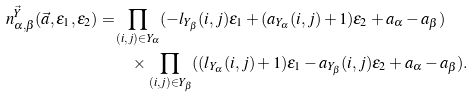Convert formula to latex. <formula><loc_0><loc_0><loc_500><loc_500>n _ { \alpha , \beta } ^ { \vec { Y } } ( \vec { a } , \epsilon _ { 1 } , \epsilon _ { 2 } ) = & \prod _ { ( i , j ) \in Y _ { \alpha } } ( - l _ { Y _ { \beta } } ( i , j ) \epsilon _ { 1 } + ( a _ { Y _ { \alpha } } ( i , j ) + 1 ) \epsilon _ { 2 } + a _ { \alpha } - a _ { \beta } ) \\ & \quad \times \prod _ { ( i , j ) \in Y _ { \beta } } ( ( l _ { Y _ { \alpha } } ( i , j ) + 1 ) \epsilon _ { 1 } - a _ { Y _ { \beta } } ( i , j ) \epsilon _ { 2 } + a _ { \alpha } - a _ { \beta } ) .</formula> 